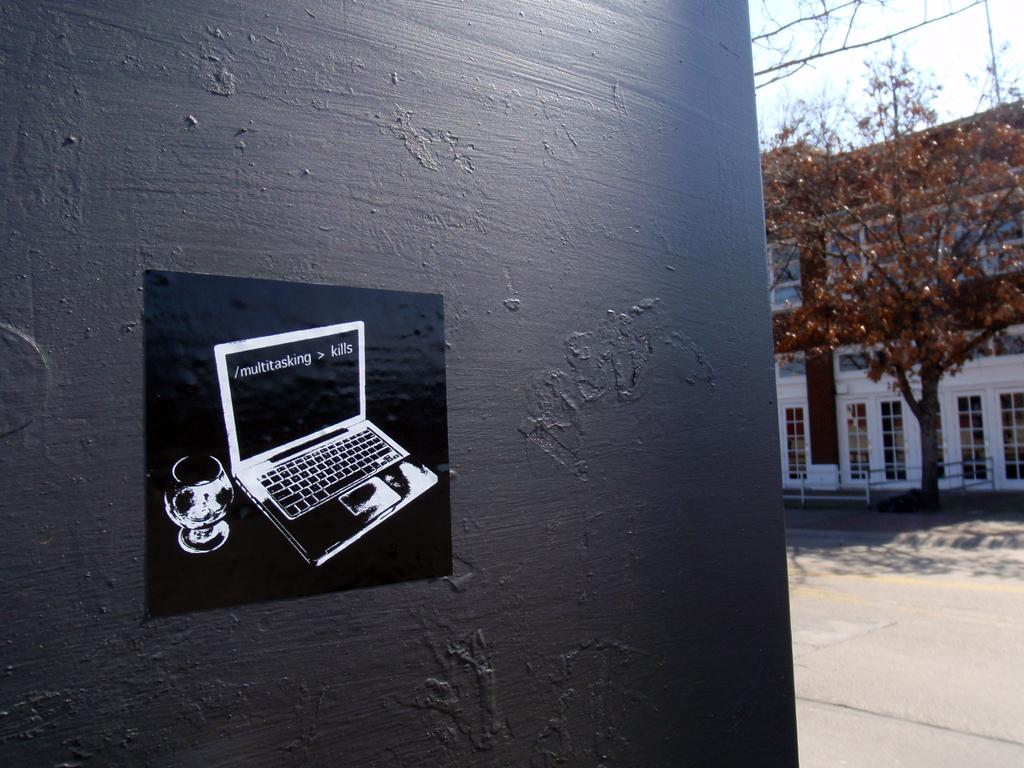<image>
Render a clear and concise summary of the photo. Sticker of a laptop on a wall that says multitasking on the screen. 